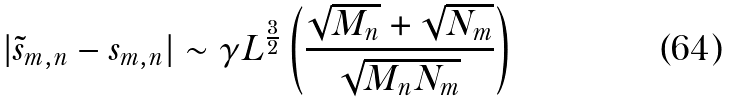<formula> <loc_0><loc_0><loc_500><loc_500>| \tilde { s } _ { m , n } - s _ { m , n } | \sim \gamma L ^ { \frac { 3 } { 2 } } \left ( \frac { \sqrt { M _ { n } } + \sqrt { N _ { m } } } { \sqrt { M _ { n } N _ { m } } } \right )</formula> 